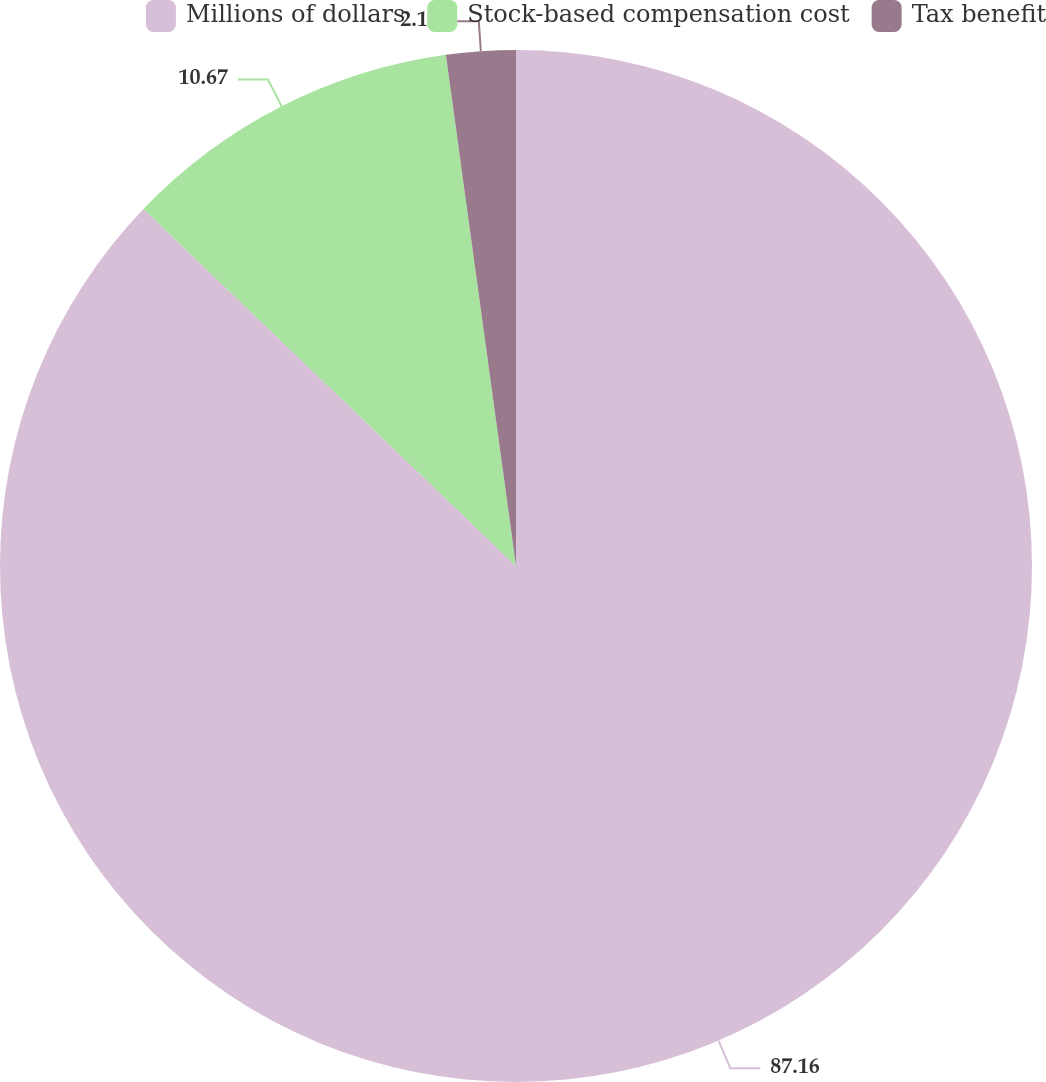Convert chart. <chart><loc_0><loc_0><loc_500><loc_500><pie_chart><fcel>Millions of dollars<fcel>Stock-based compensation cost<fcel>Tax benefit<nl><fcel>87.16%<fcel>10.67%<fcel>2.17%<nl></chart> 